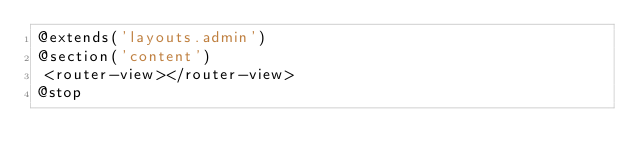Convert code to text. <code><loc_0><loc_0><loc_500><loc_500><_PHP_>@extends('layouts.admin')
@section('content')
 <router-view></router-view>
@stop
</code> 